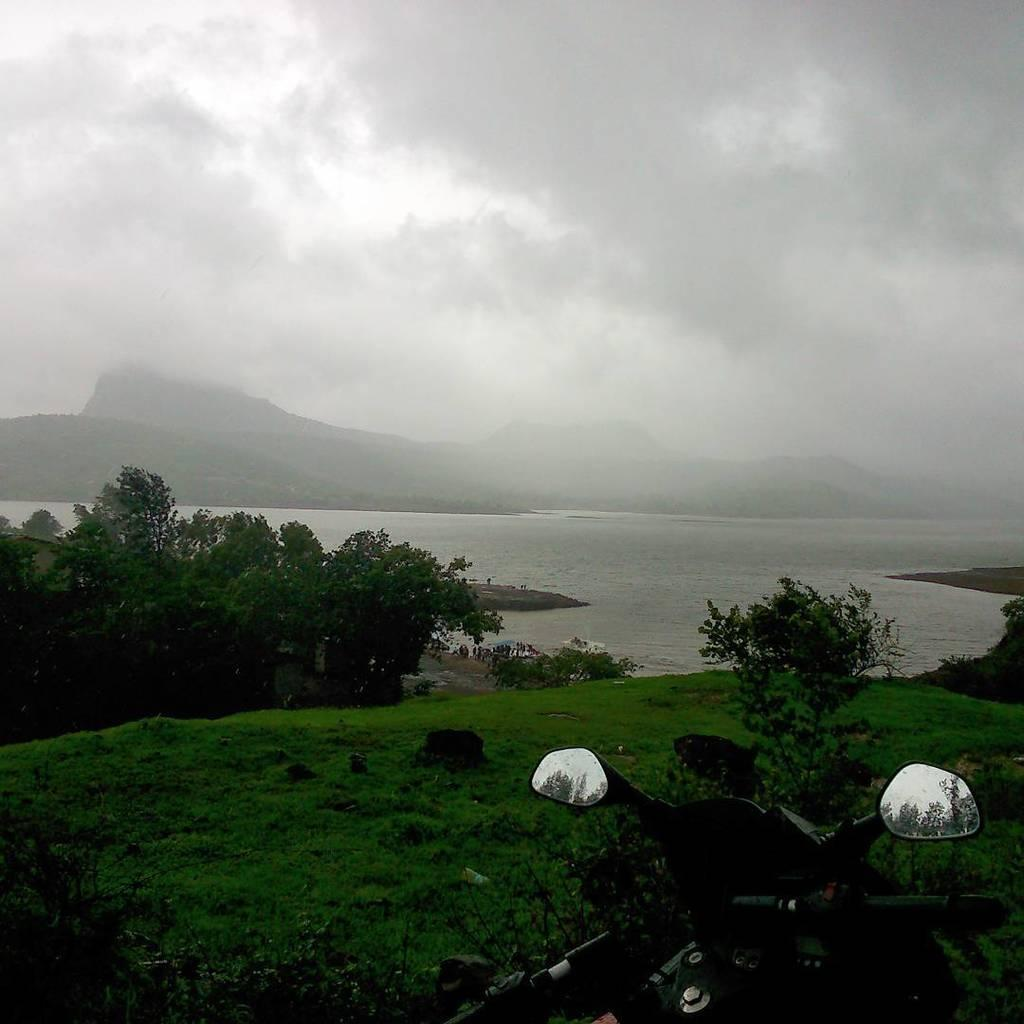What type of scenery is depicted in the image? The image contains a beautiful scenery. What type of vegetation is present in the image? There is grass in the image. Can you describe the location of the vehicle in the image? A vehicle is parked on the grass in the image. What other natural elements can be seen in the image? There are trees in the image. Where are the trees located in relation to the other elements? The trees are in the front of the image. What body of water is visible in the image? There is a sea beside the trees in the image. What type of pickle is being used as a decoration on the vehicle in the image? There is no pickle present in the image, and therefore no such decoration can be observed. What happens when the cap on the sea bursts in the image? There is no cap on the sea in the image, and therefore no such event can occur. 